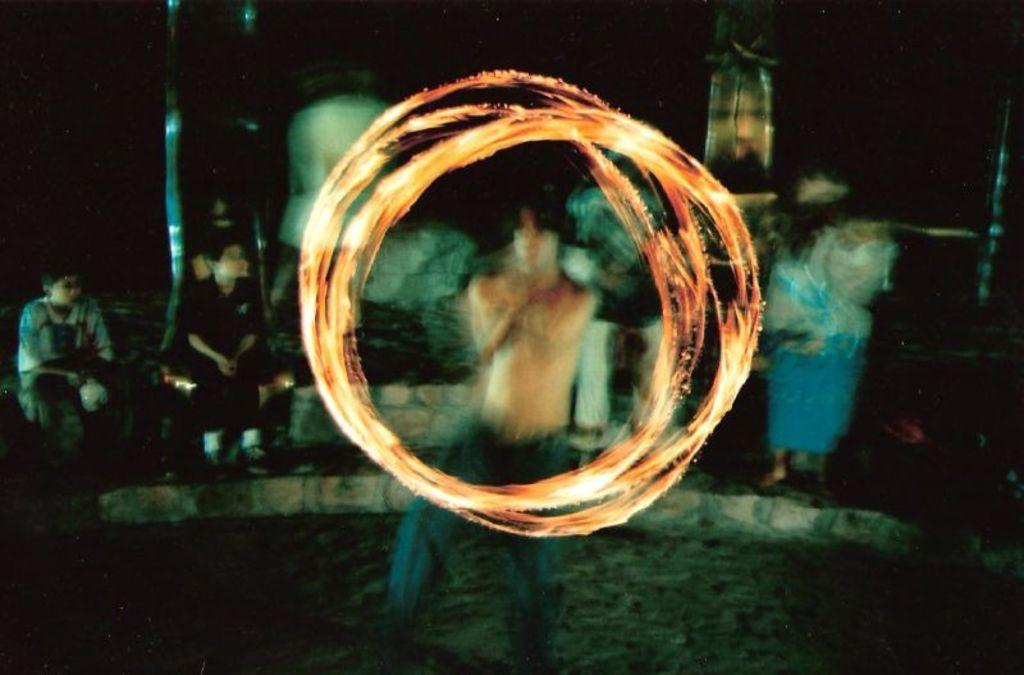What is the main subject of the image? There is a person standing in the image. What is in front of the person? There is a fire ring in front of the person. What can be seen in the background of the image? There are people sitting and other objects visible in the background of the image. How would you describe the lighting in the image? The background of the image is dark. What type of crook is the person holding in the image? There is no crook present in the image. What is the person writing in the image? There is no indication that the person is writing in the image. 